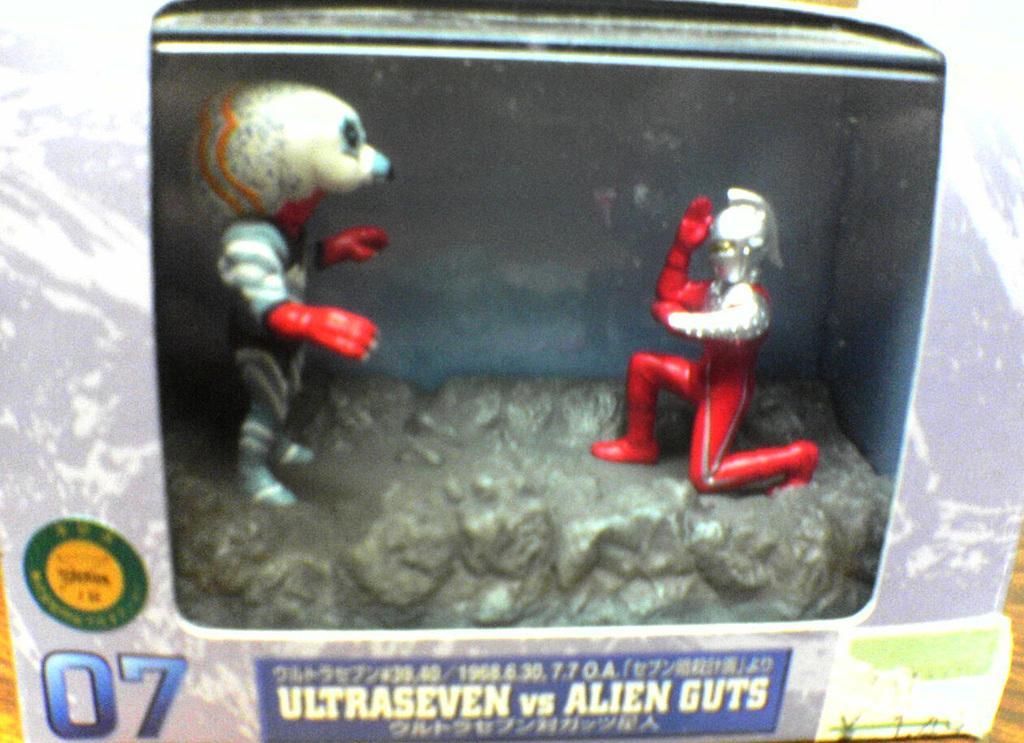Can you describe this image briefly? This image consists of dolls kept in a box. At the bottom, there is text. 